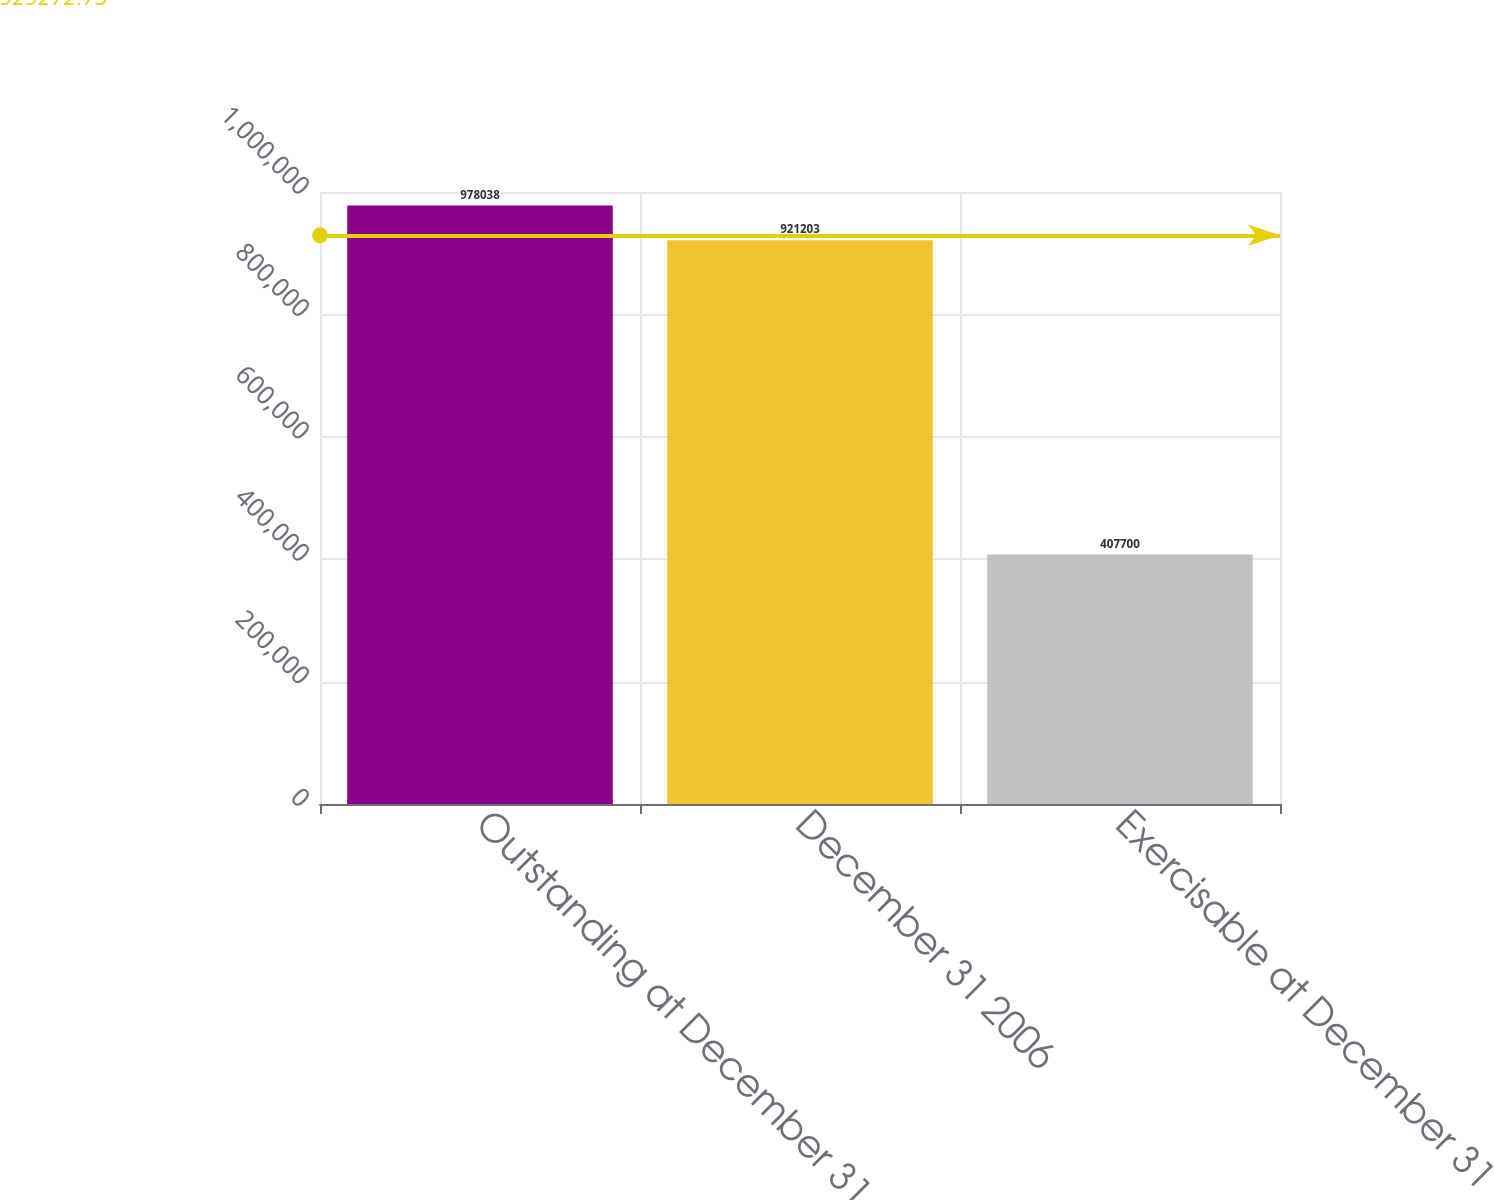Convert chart. <chart><loc_0><loc_0><loc_500><loc_500><bar_chart><fcel>Outstanding at December 31<fcel>December 31 2006<fcel>Exercisable at December 31<nl><fcel>978038<fcel>921203<fcel>407700<nl></chart> 